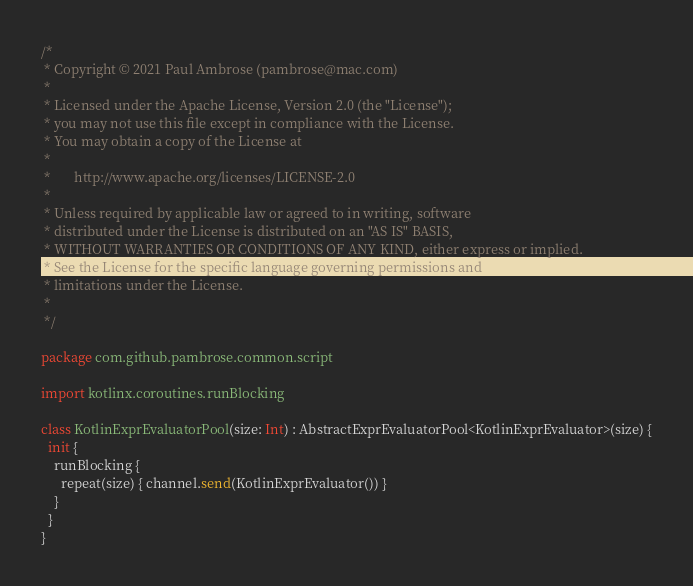Convert code to text. <code><loc_0><loc_0><loc_500><loc_500><_Kotlin_>/*
 * Copyright © 2021 Paul Ambrose (pambrose@mac.com)
 *
 * Licensed under the Apache License, Version 2.0 (the "License");
 * you may not use this file except in compliance with the License.
 * You may obtain a copy of the License at
 *
 *       http://www.apache.org/licenses/LICENSE-2.0
 *
 * Unless required by applicable law or agreed to in writing, software
 * distributed under the License is distributed on an "AS IS" BASIS,
 * WITHOUT WARRANTIES OR CONDITIONS OF ANY KIND, either express or implied.
 * See the License for the specific language governing permissions and
 * limitations under the License.
 *
 */

package com.github.pambrose.common.script

import kotlinx.coroutines.runBlocking

class KotlinExprEvaluatorPool(size: Int) : AbstractExprEvaluatorPool<KotlinExprEvaluator>(size) {
  init {
    runBlocking {
      repeat(size) { channel.send(KotlinExprEvaluator()) }
    }
  }
}
</code> 